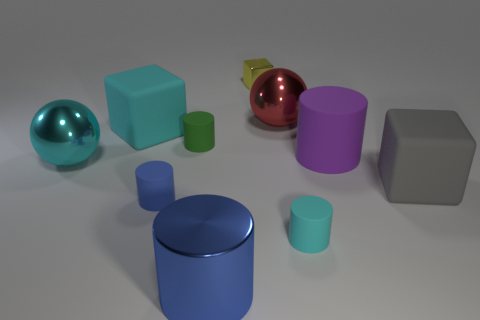How many blue cylinders must be subtracted to get 1 blue cylinders? 1 Subtract 2 cylinders. How many cylinders are left? 3 Subtract all tiny green cylinders. How many cylinders are left? 4 Subtract all purple cylinders. How many cylinders are left? 4 Subtract all yellow cylinders. Subtract all blue balls. How many cylinders are left? 5 Subtract all cubes. How many objects are left? 7 Add 1 tiny red rubber spheres. How many tiny red rubber spheres exist? 1 Subtract 0 blue balls. How many objects are left? 10 Subtract all big metal spheres. Subtract all large yellow cylinders. How many objects are left? 8 Add 1 large metallic cylinders. How many large metallic cylinders are left? 2 